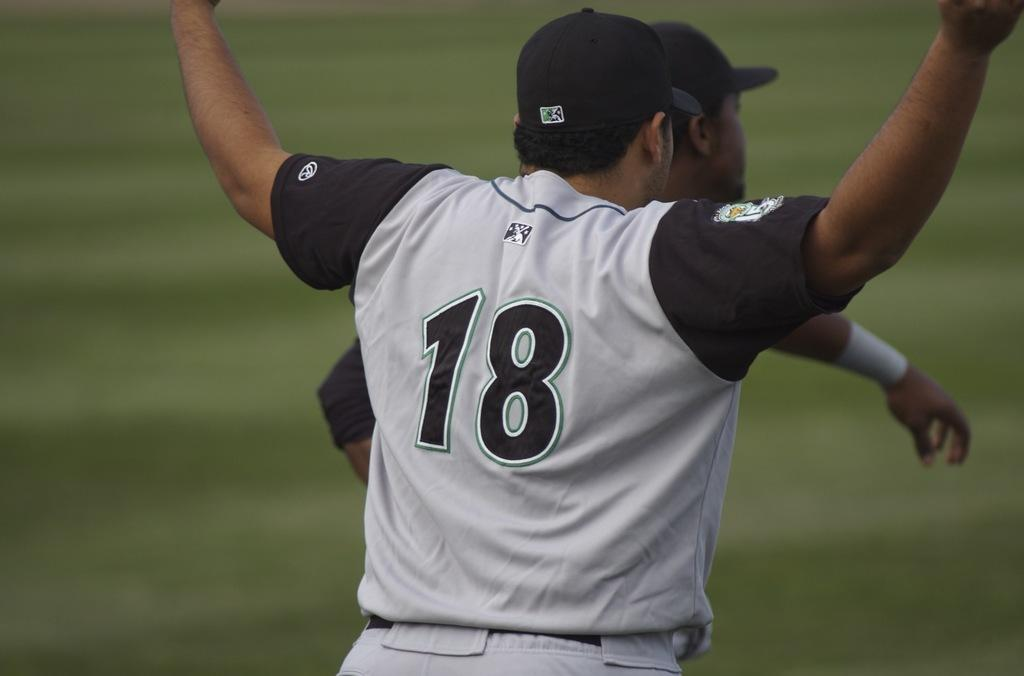<image>
Create a compact narrative representing the image presented. Number eighteen design on a black and gray jersey 